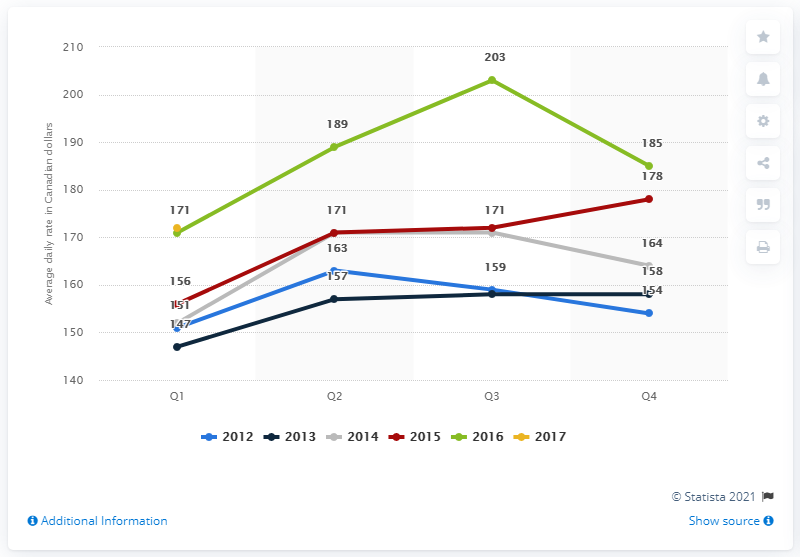Point out several critical features in this image. In the first quarter of 2017, the average daily rate of hotels in Montreal, Canada was 172 dollars. In 2016, the green line fluctuated from Q1 to Q3, showing a movement of 32 points. The green line chart shows the highest value to be 203. 